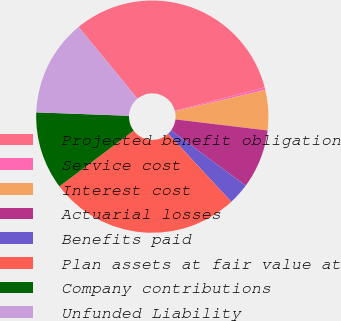Convert chart. <chart><loc_0><loc_0><loc_500><loc_500><pie_chart><fcel>Projected benefit obligation<fcel>Service cost<fcel>Interest cost<fcel>Actuarial losses<fcel>Benefits paid<fcel>Plan assets at fair value at<fcel>Company contributions<fcel>Unfunded Liability<nl><fcel>31.89%<fcel>0.36%<fcel>5.6%<fcel>8.22%<fcel>2.98%<fcel>26.65%<fcel>10.84%<fcel>13.46%<nl></chart> 